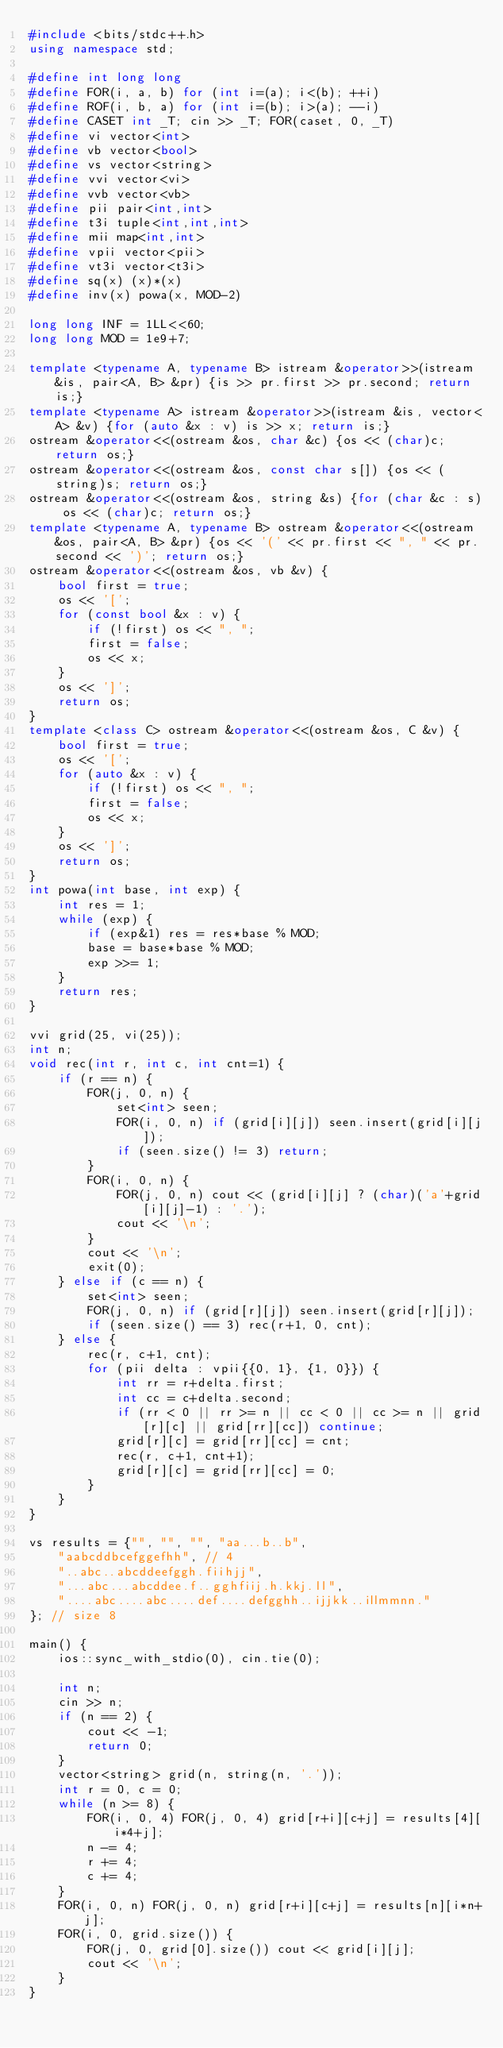<code> <loc_0><loc_0><loc_500><loc_500><_C++_>#include <bits/stdc++.h>
using namespace std;
 
#define int long long
#define FOR(i, a, b) for (int i=(a); i<(b); ++i)
#define ROF(i, b, a) for (int i=(b); i>(a); --i)
#define CASET int _T; cin >> _T; FOR(caset, 0, _T)
#define vi vector<int>
#define vb vector<bool>
#define vs vector<string>
#define vvi vector<vi>
#define vvb vector<vb>
#define pii pair<int,int>
#define t3i tuple<int,int,int>
#define mii map<int,int>
#define vpii vector<pii>
#define vt3i vector<t3i>
#define sq(x) (x)*(x)
#define inv(x) powa(x, MOD-2)
 
long long INF = 1LL<<60;
long long MOD = 1e9+7;
 
template <typename A, typename B> istream &operator>>(istream &is, pair<A, B> &pr) {is >> pr.first >> pr.second; return is;}
template <typename A> istream &operator>>(istream &is, vector<A> &v) {for (auto &x : v) is >> x; return is;}
ostream &operator<<(ostream &os, char &c) {os << (char)c; return os;}
ostream &operator<<(ostream &os, const char s[]) {os << (string)s; return os;}
ostream &operator<<(ostream &os, string &s) {for (char &c : s) os << (char)c; return os;}
template <typename A, typename B> ostream &operator<<(ostream &os, pair<A, B> &pr) {os << '(' << pr.first << ", " << pr.second << ')'; return os;}
ostream &operator<<(ostream &os, vb &v) {
    bool first = true;
    os << '[';
    for (const bool &x : v) {
        if (!first) os << ", ";
        first = false;
        os << x;
    }
    os << ']';
    return os;
}
template <class C> ostream &operator<<(ostream &os, C &v) {
    bool first = true;
    os << '[';
    for (auto &x : v) {
        if (!first) os << ", ";
        first = false;
        os << x;
    }
    os << ']';
    return os;
}
int powa(int base, int exp) {
    int res = 1;
    while (exp) {
        if (exp&1) res = res*base % MOD;
        base = base*base % MOD;
        exp >>= 1;
    }
    return res;
}

vvi grid(25, vi(25));
int n;
void rec(int r, int c, int cnt=1) {
    if (r == n) {
        FOR(j, 0, n) {
            set<int> seen;
            FOR(i, 0, n) if (grid[i][j]) seen.insert(grid[i][j]);
            if (seen.size() != 3) return;
        }
        FOR(i, 0, n) {
            FOR(j, 0, n) cout << (grid[i][j] ? (char)('a'+grid[i][j]-1) : '.');
            cout << '\n';
        }
        cout << '\n';
        exit(0);
    } else if (c == n) {
        set<int> seen;
        FOR(j, 0, n) if (grid[r][j]) seen.insert(grid[r][j]);
        if (seen.size() == 3) rec(r+1, 0, cnt);
    } else {
        rec(r, c+1, cnt);
        for (pii delta : vpii{{0, 1}, {1, 0}}) {
            int rr = r+delta.first;
            int cc = c+delta.second;
            if (rr < 0 || rr >= n || cc < 0 || cc >= n || grid[r][c] || grid[rr][cc]) continue;
            grid[r][c] = grid[rr][cc] = cnt;
            rec(r, c+1, cnt+1);
            grid[r][c] = grid[rr][cc] = 0;
        }
    }
}

vs results = {"", "", "", "aa...b..b",
    "aabcddbcefggefhh", // 4
    "..abc..abcddeefggh.fiihjj",
    "...abc...abcddee.f..gghfiij.h.kkj.ll",
    "....abc....abc....def....defgghh..ijjkk..illmmnn."
}; // size 8

main() {
    ios::sync_with_stdio(0), cin.tie(0);
    
    int n;
    cin >> n;
    if (n == 2) {
        cout << -1;
        return 0;
    }
    vector<string> grid(n, string(n, '.'));
    int r = 0, c = 0;
    while (n >= 8) {
        FOR(i, 0, 4) FOR(j, 0, 4) grid[r+i][c+j] = results[4][i*4+j];
        n -= 4;
        r += 4;
        c += 4;
    }
    FOR(i, 0, n) FOR(j, 0, n) grid[r+i][c+j] = results[n][i*n+j];
    FOR(i, 0, grid.size()) {
        FOR(j, 0, grid[0].size()) cout << grid[i][j];
        cout << '\n';
    }
}</code> 